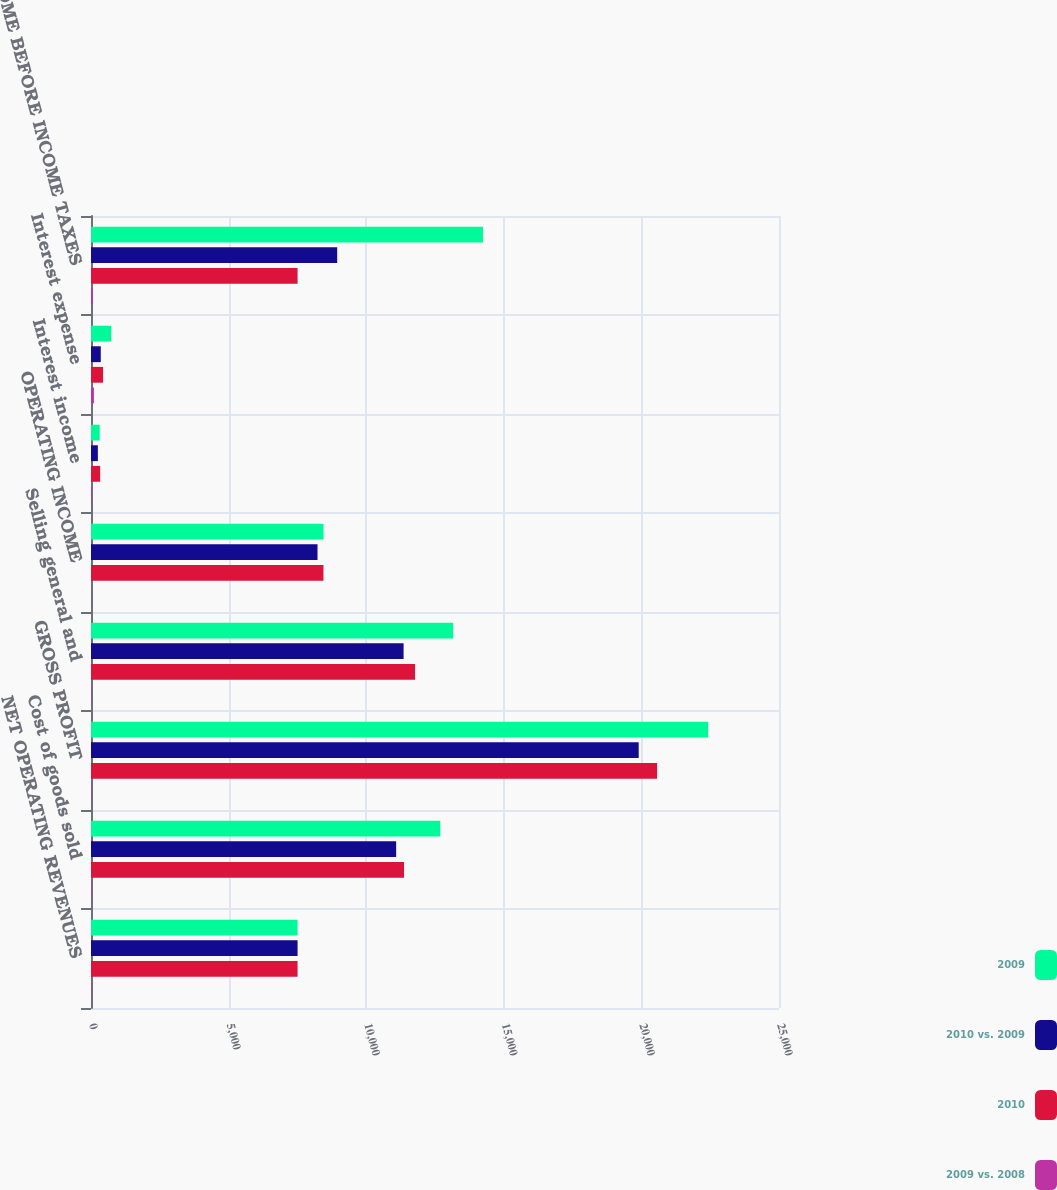<chart> <loc_0><loc_0><loc_500><loc_500><stacked_bar_chart><ecel><fcel>NET OPERATING REVENUES<fcel>Cost of goods sold<fcel>GROSS PROFIT<fcel>Selling general and<fcel>OPERATING INCOME<fcel>Interest income<fcel>Interest expense<fcel>INCOME BEFORE INCOME TAXES<nl><fcel>2009<fcel>7506<fcel>12693<fcel>22426<fcel>13158<fcel>8449<fcel>317<fcel>733<fcel>14243<nl><fcel>2010 vs. 2009<fcel>7506<fcel>11088<fcel>19902<fcel>11358<fcel>8231<fcel>249<fcel>355<fcel>8946<nl><fcel>2010<fcel>7506<fcel>11374<fcel>20570<fcel>11774<fcel>8446<fcel>333<fcel>438<fcel>7506<nl><fcel>2009 vs. 2008<fcel>13<fcel>14<fcel>13<fcel>16<fcel>3<fcel>27<fcel>106<fcel>59<nl></chart> 